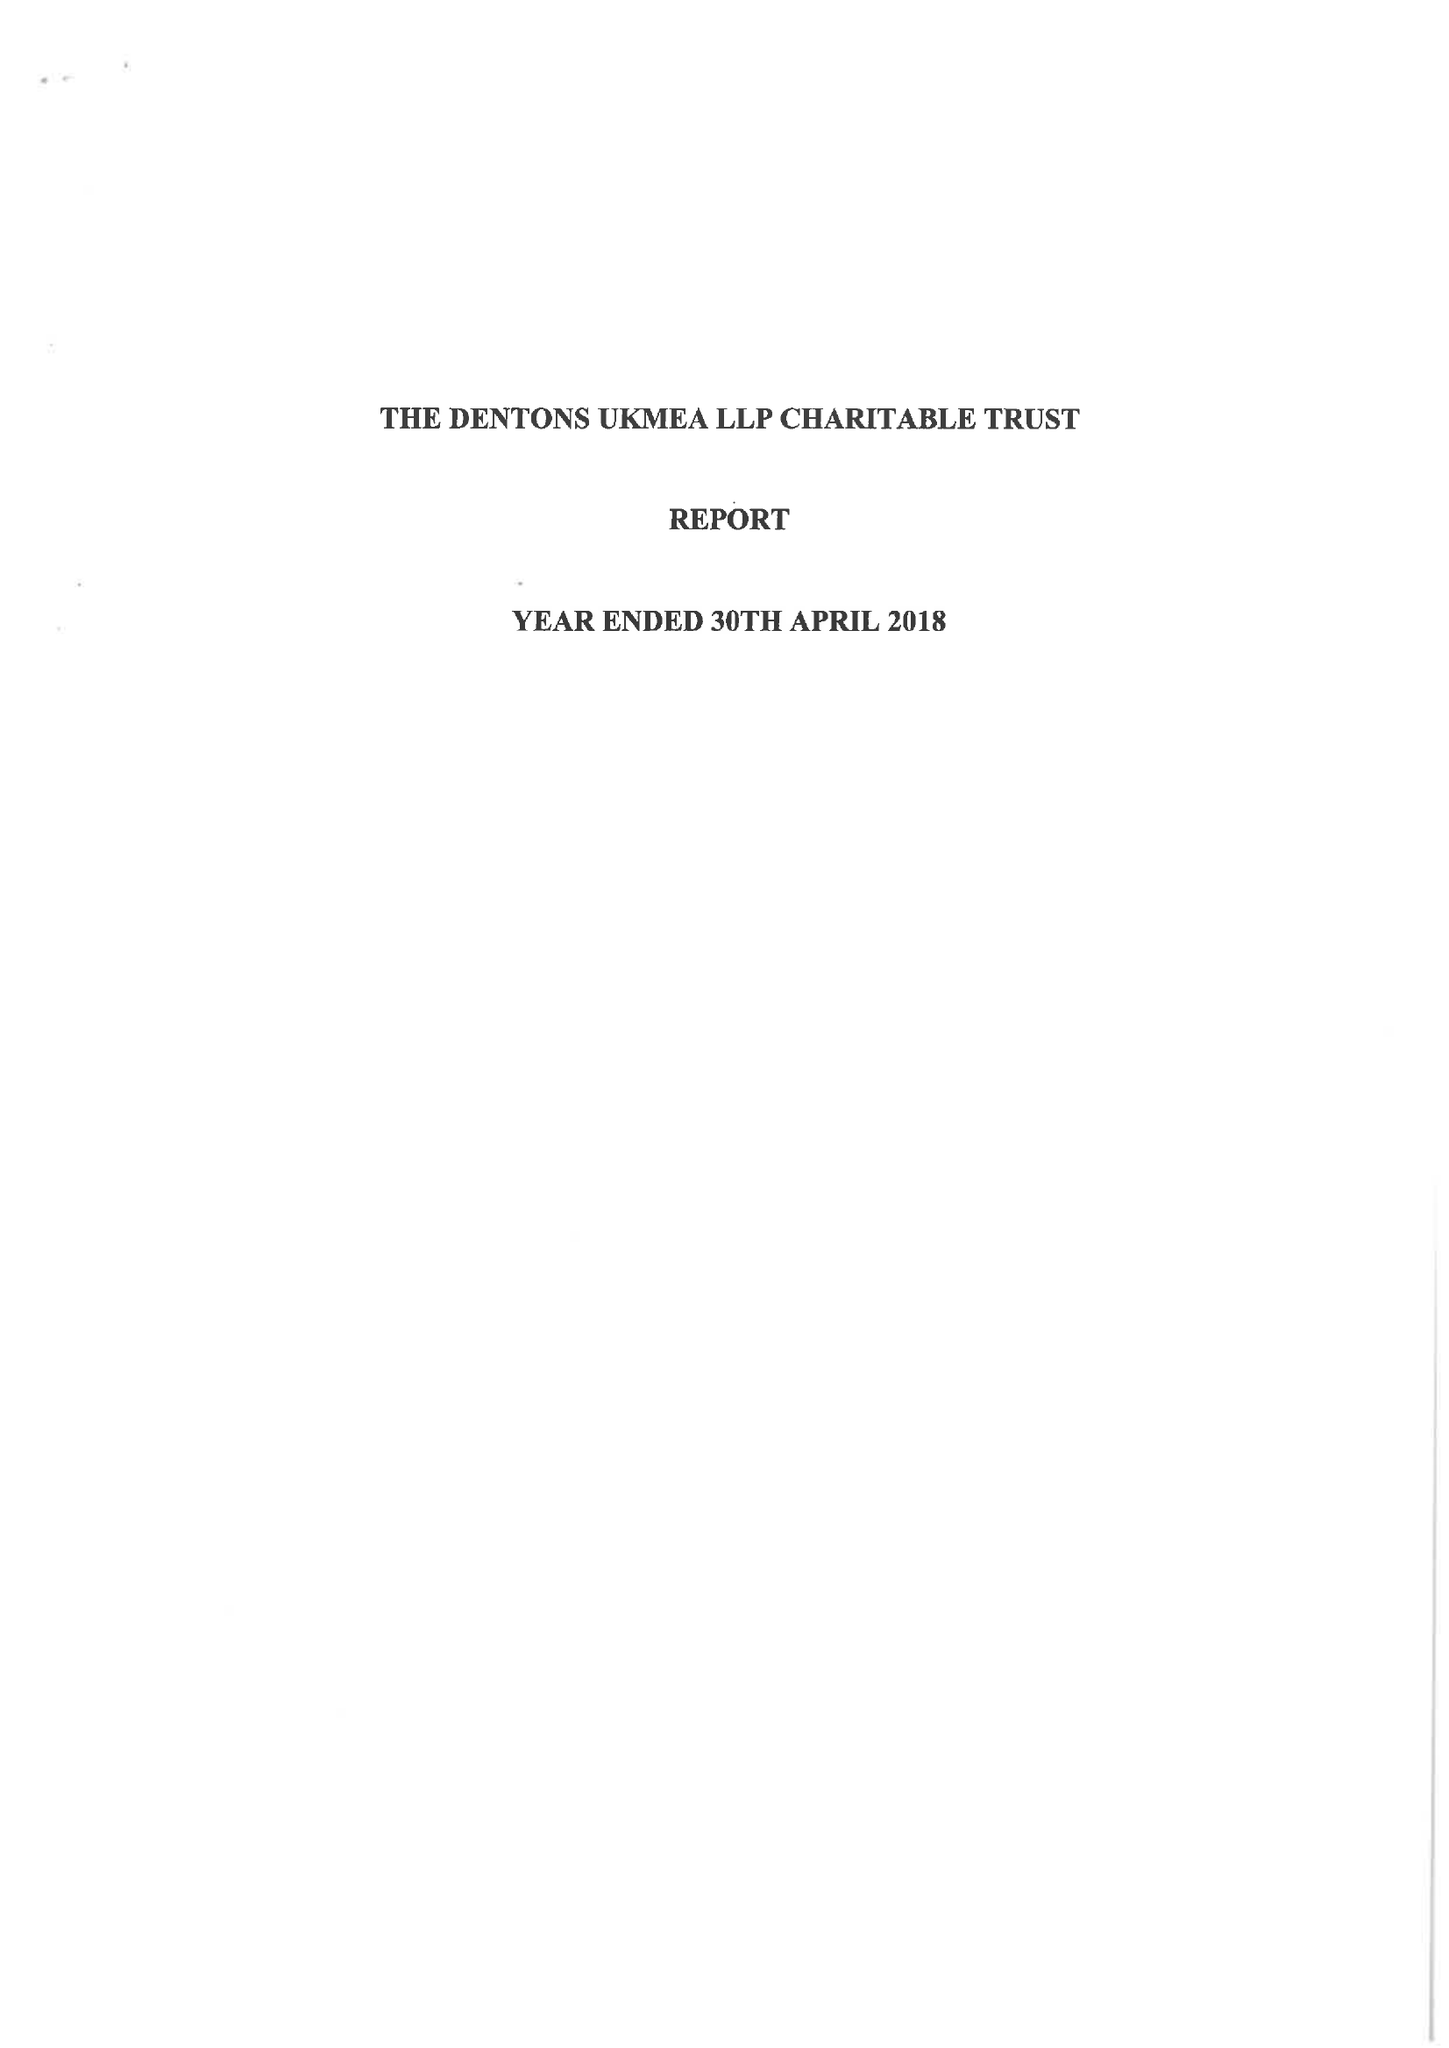What is the value for the address__street_line?
Answer the question using a single word or phrase. None 